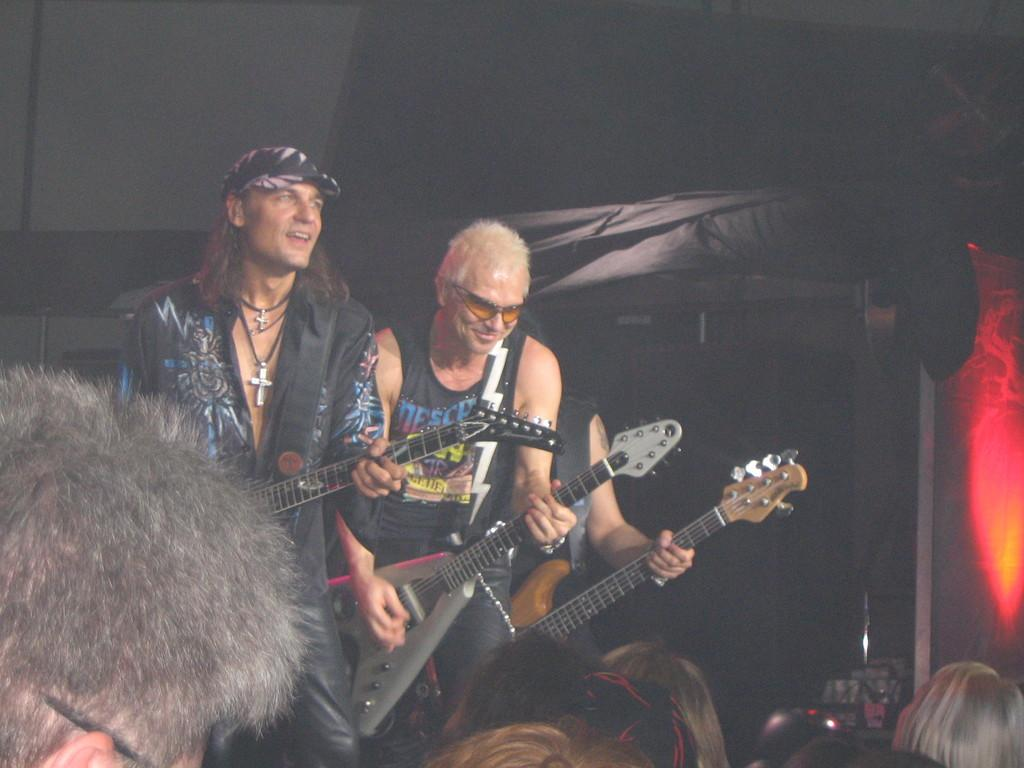What are the people in the image wearing? The people in the image are wearing black dress. What activity are the people engaged in? The people are playing guitar. Can you describe the group of people in front of the guitar players? There is a group of people in front of the guitar players. What type of alley can be seen behind the guitar players in the image? There is no alley visible in the image; it only shows people playing guitar and a group of people in front of them. 